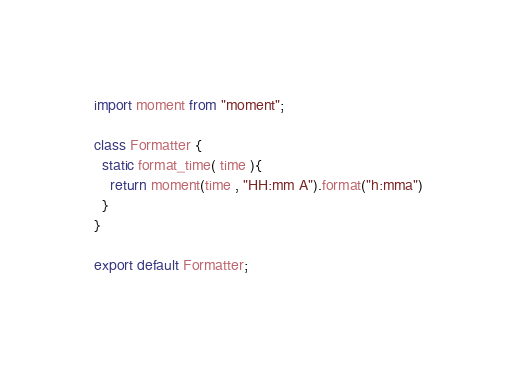<code> <loc_0><loc_0><loc_500><loc_500><_JavaScript_>import moment from "moment";

class Formatter {
  static format_time( time ){
    return moment(time , "HH:mm A").format("h:mma")
  }
}

export default Formatter;
</code> 